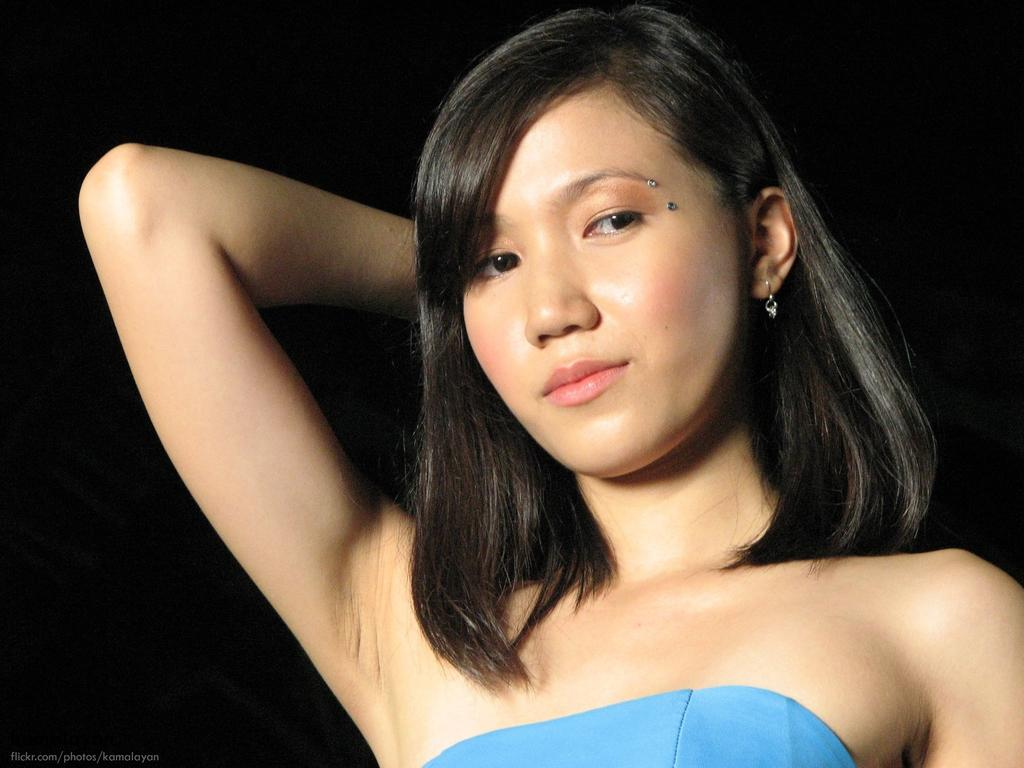What is the main subject of the image? There is a person standing in the image. What can be found at the bottom of the image? There is text at the bottom of the image. How would you describe the background of the image? The background of the image is dark. What type of reaction can be seen on the person's teeth in the image? There are no teeth visible in the image, so it is not possible to determine any reaction on them. 